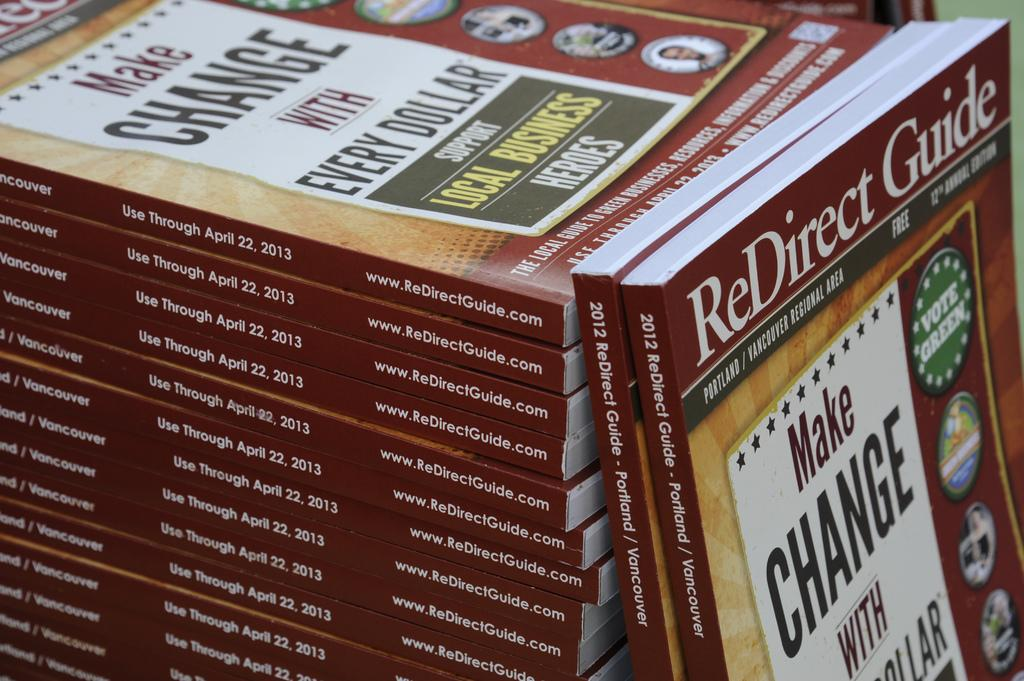<image>
Relay a brief, clear account of the picture shown. A stack of the Redirect Guide is from 2012. 